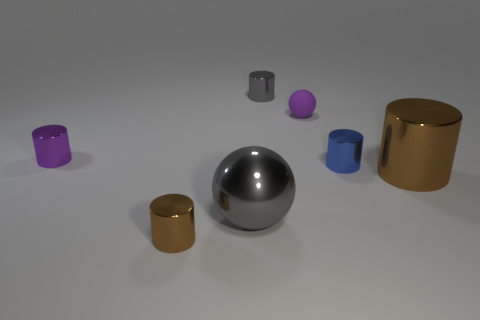Subtract all brown cylinders. How many cylinders are left? 3 Subtract all green balls. How many brown cylinders are left? 2 Add 3 purple shiny things. How many objects exist? 10 Subtract all blue cylinders. How many cylinders are left? 4 Subtract all spheres. How many objects are left? 5 Add 5 brown rubber things. How many brown rubber things exist? 5 Subtract 1 gray spheres. How many objects are left? 6 Subtract all blue cylinders. Subtract all green spheres. How many cylinders are left? 4 Subtract all tiny purple metallic things. Subtract all gray cylinders. How many objects are left? 5 Add 3 small blue shiny cylinders. How many small blue shiny cylinders are left? 4 